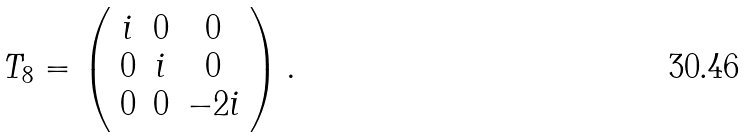Convert formula to latex. <formula><loc_0><loc_0><loc_500><loc_500>T _ { 8 } = \left ( \begin{array} { c c c } i & 0 & 0 \\ 0 & i & 0 \\ 0 & 0 & - 2 i \end{array} \right ) .</formula> 